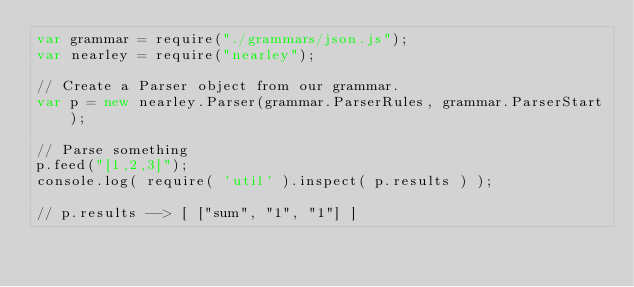<code> <loc_0><loc_0><loc_500><loc_500><_JavaScript_>var grammar = require("./grammars/json.js");
var nearley = require("nearley");

// Create a Parser object from our grammar.
var p = new nearley.Parser(grammar.ParserRules, grammar.ParserStart);

// Parse something
p.feed("[1,2,3]");
console.log( require( 'util' ).inspect( p.results ) );

// p.results --> [ ["sum", "1", "1"] ]

</code> 